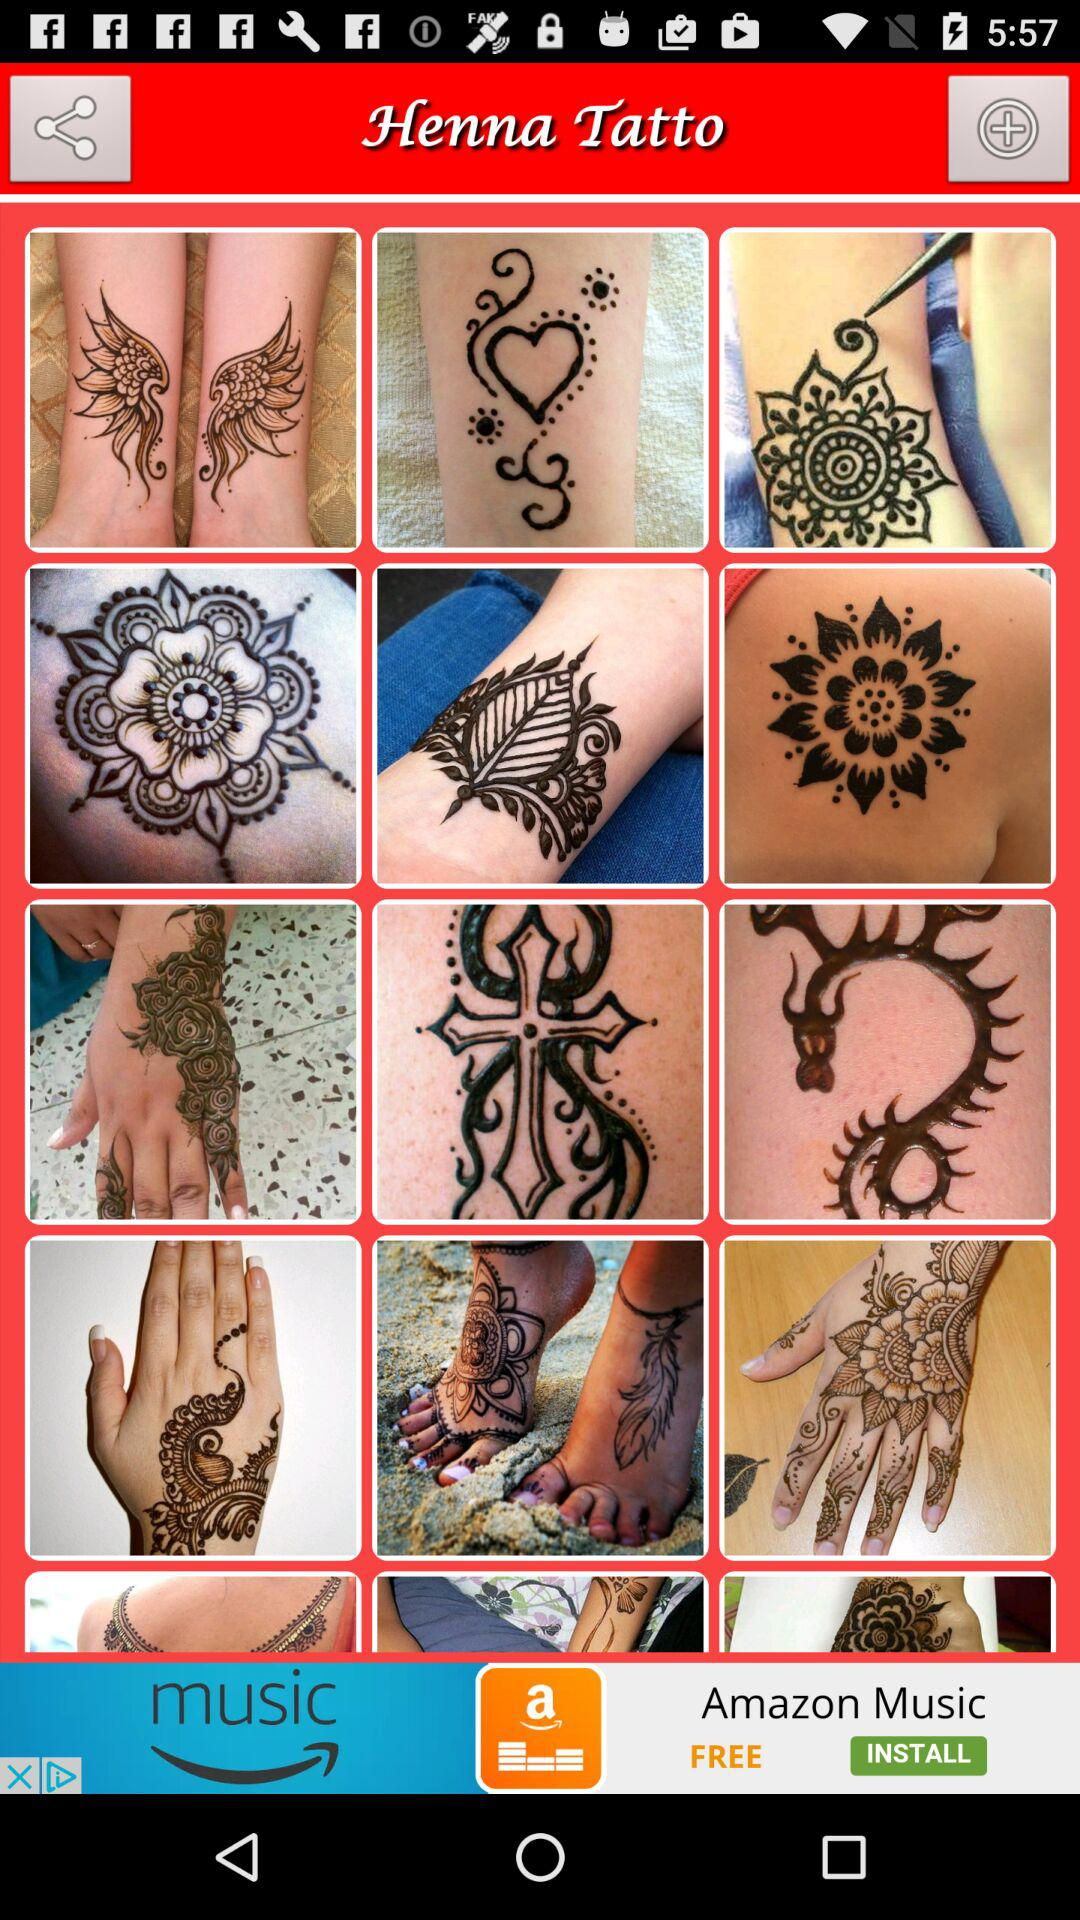How many photos can be shared?
When the provided information is insufficient, respond with <no answer>. <no answer> 